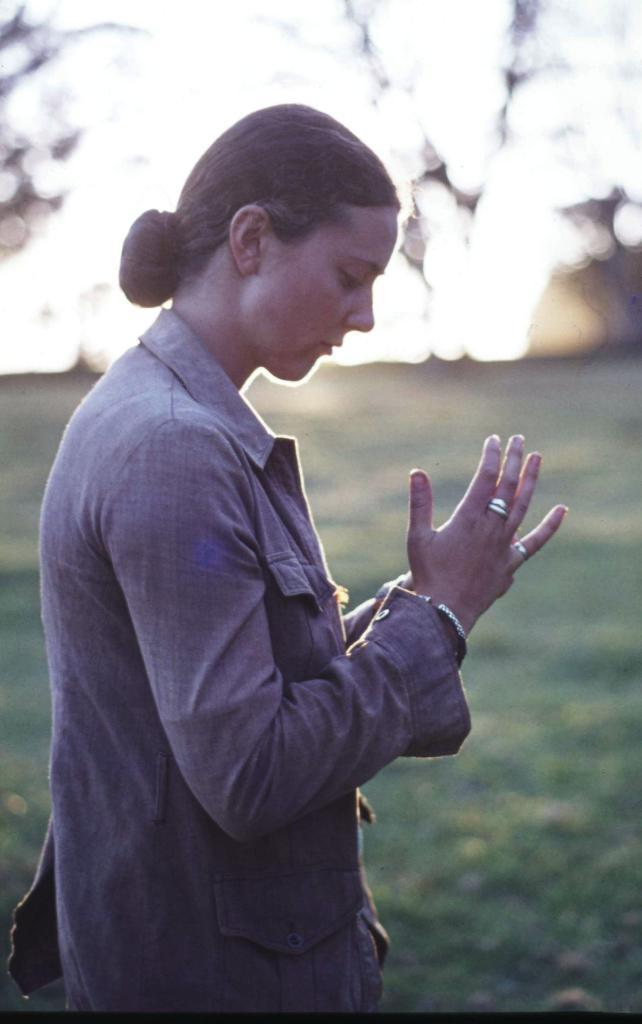Who is present in the image? There is a woman in the image. What can be seen in the background of the image? Sun rays are visible in the background of the image. How would you describe the background of the image? The background of the image is blurred. What type of pollution can be seen in the image? There is no pollution visible in the image; it features a woman and sun rays in a blurred background. What message of peace is conveyed by the image? The image does not convey a specific message of peace; it simply shows a woman and sun rays in a blurred background. 